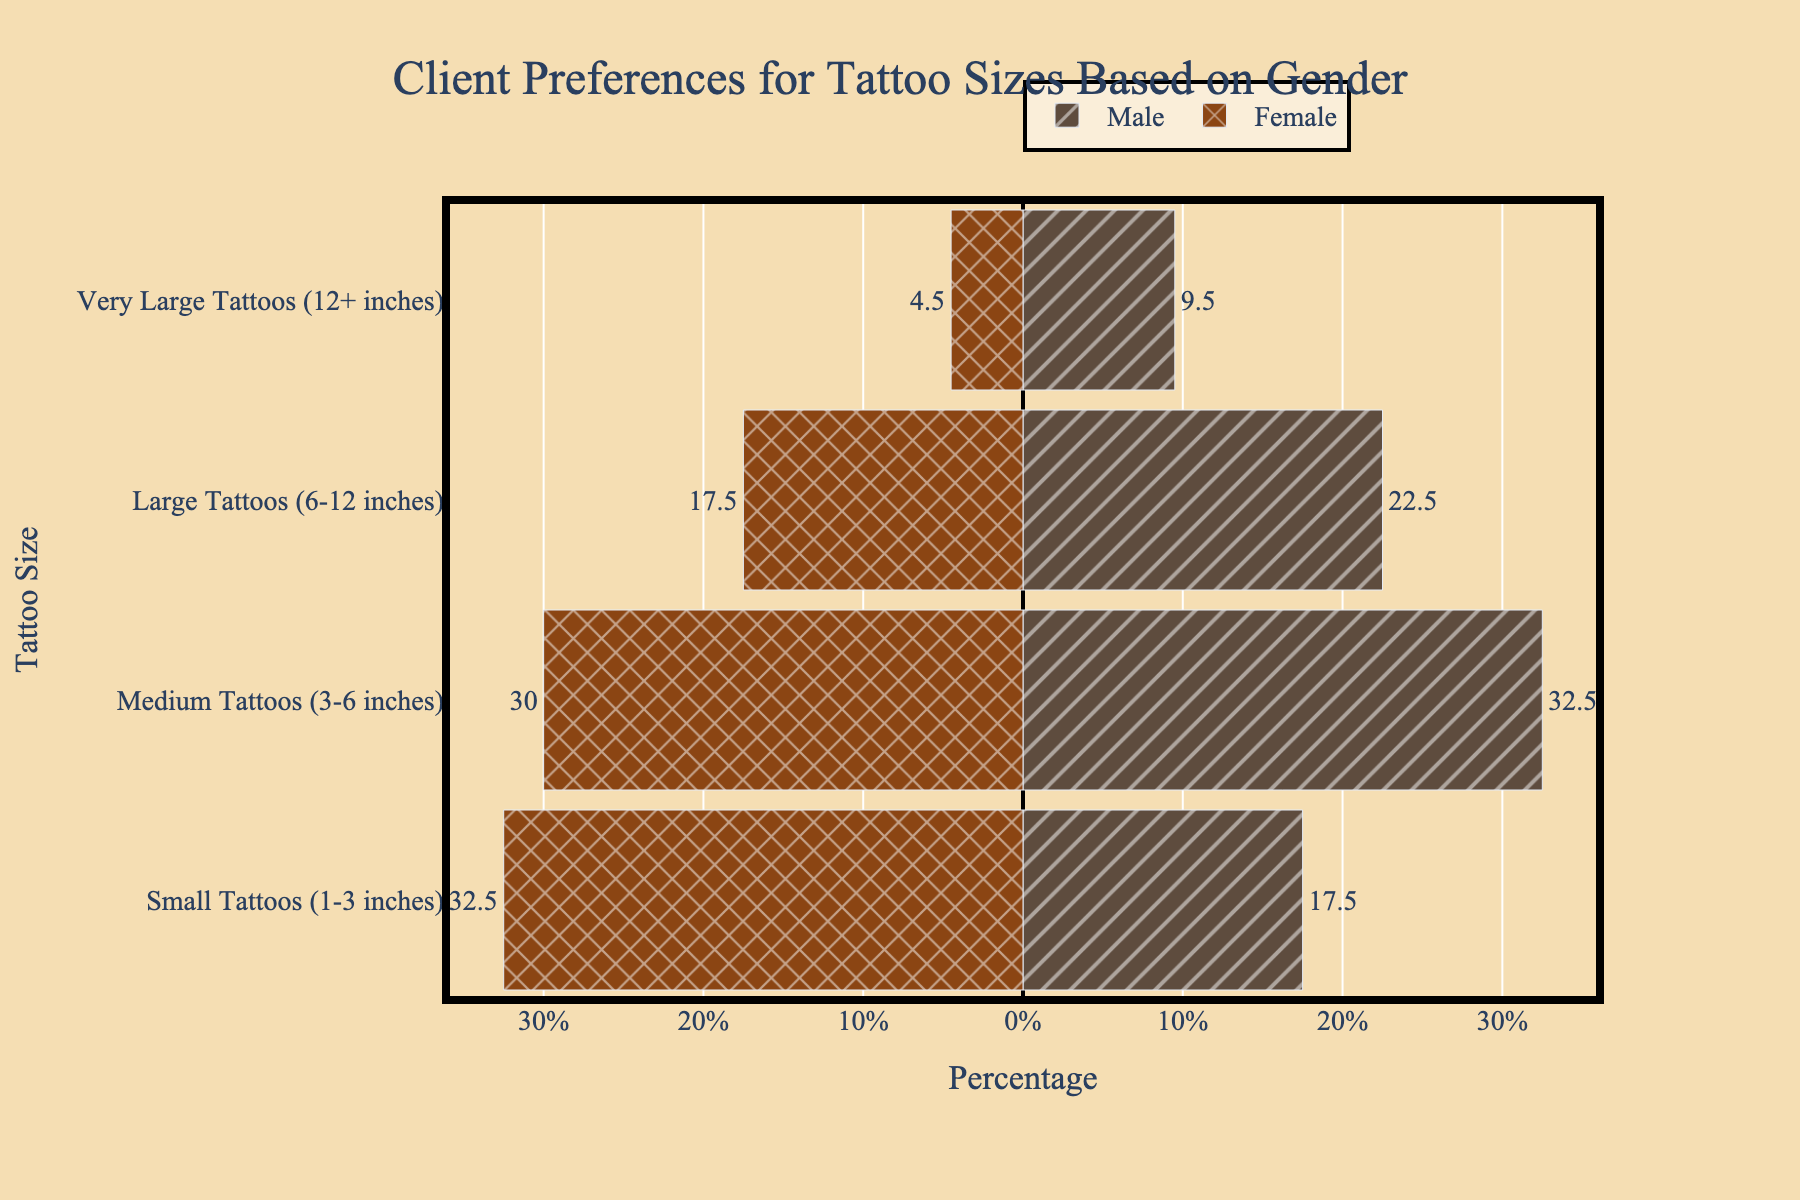What's the overall number of Small Tattoos preferred by males and females? Sum the average percentages of Small Tattoos for males (20%) and females (32.5%). The calculation is 20 + 32.5 = 52.5%.
Answer: 52.5% Which gender prefers Medium Tattoos more? Compare the average percentage of Medium Tattoos for males (32.5%) and females (30%). Males have a higher percentage (32.5% > 30%).
Answer: Males What is the largest percentage difference between genders for a tattoo size? Calculate the absolute differences for each size: Small (12.5%), Medium (2.5%), Large (11.3%), Very Large (4.2%). The largest is for Small Tattoos (12.5%).
Answer: Small Tattoos Which tattoo size has the closest preference percentage between genders? Compare the absolute differences for each size: Small (12.5%), Medium (2.5%), Large (11.3%), Very Large (4.2%). Medium Tattoos have the smallest difference (2.5%).
Answer: Medium Tattoos What percentage of clients prefer Large Tattoos, and how does it compare between genders? The average percentage for Large Tattoos for males is 22.5% and for females is 17.5%. Compare them: 22.5% for males and 17.5% for females.
Answer: Males prefer 22.5%, females 17.5% Is there a tattoo size where females prefer more than males? Compare all categories: Small (Females 32.5%, Males 20%), Medium (Females 30%, Males 32.5%), Large (Females 17.5%, Males 22.5%), Very Large (Females 4.5%, Males 9.5%). Only Small Tattoos are preferred more by females.
Answer: Small Tattoos Which tattoo size shows the least preference overall? Compare the total percentages for each category by summing male and female averages: Small (52.5%), Medium (62.5%), Large (40%), Very Large (14%). Very Large Tattoos have the smallest percentage (14%).
Answer: Very Large Tattoos Considering all tattoo sizes, which category shows the greatest total preference? Sum the percentages for males and females for each category: Small (52.5%), Medium (62.5%), Large (40%), Very Large (14%). Medium Tattoos show the greatest total preference (62.5%).
Answer: Medium Tattoos If you were to recommend a design based on gender preferences, which size would you recommend for females? The size with the highest average percentage for females is Small Tattoos (32.5%).
Answer: Small Tattoos 